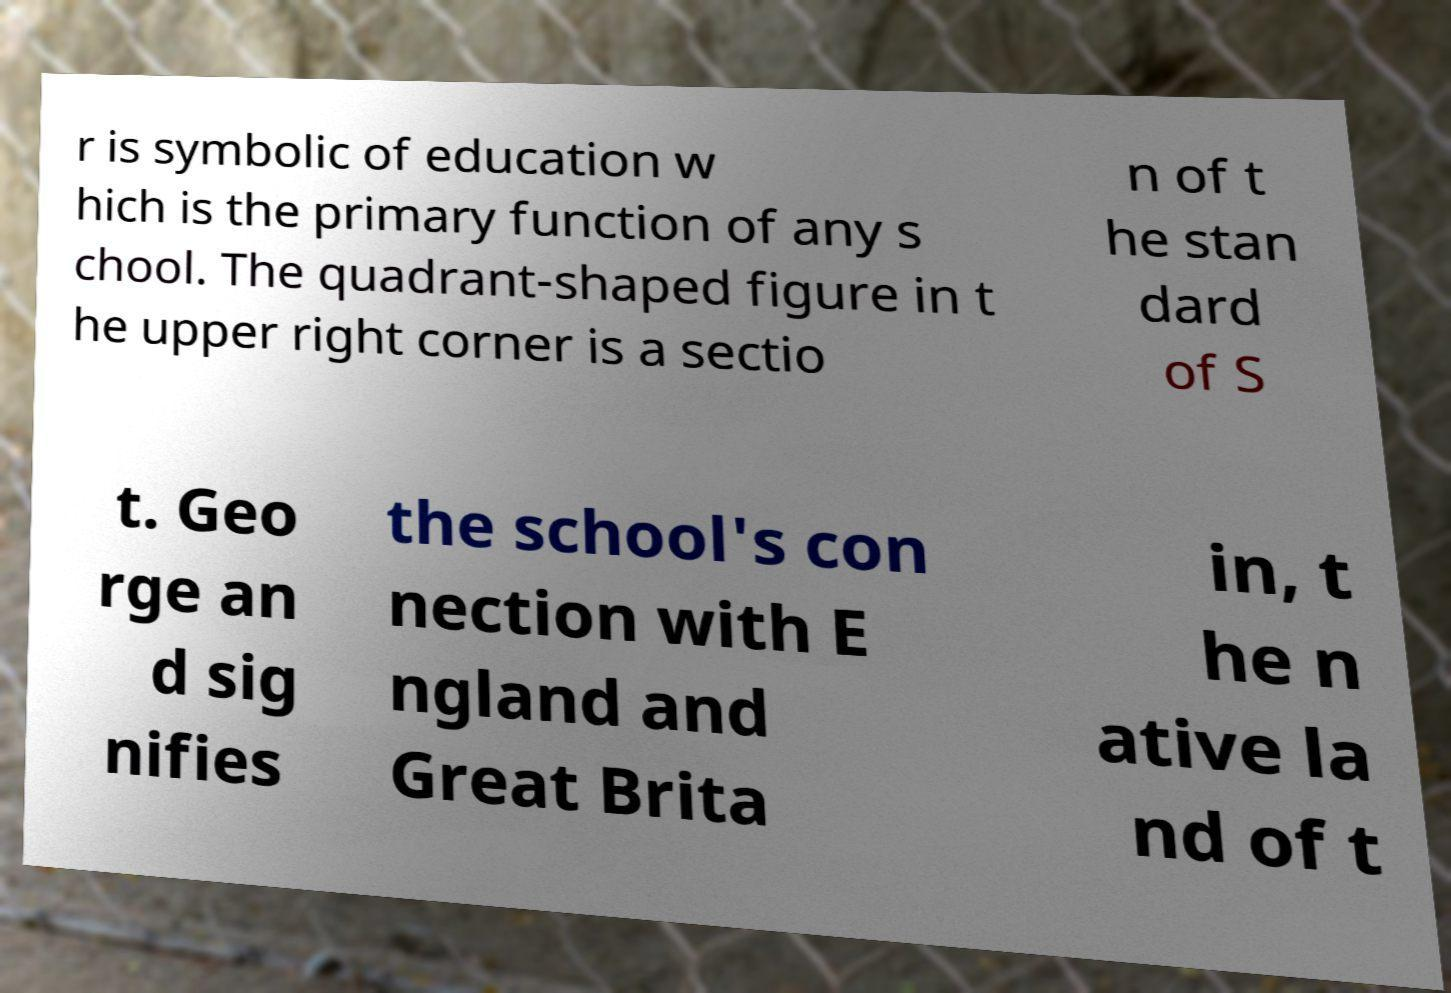Please identify and transcribe the text found in this image. r is symbolic of education w hich is the primary function of any s chool. The quadrant-shaped figure in t he upper right corner is a sectio n of t he stan dard of S t. Geo rge an d sig nifies the school's con nection with E ngland and Great Brita in, t he n ative la nd of t 